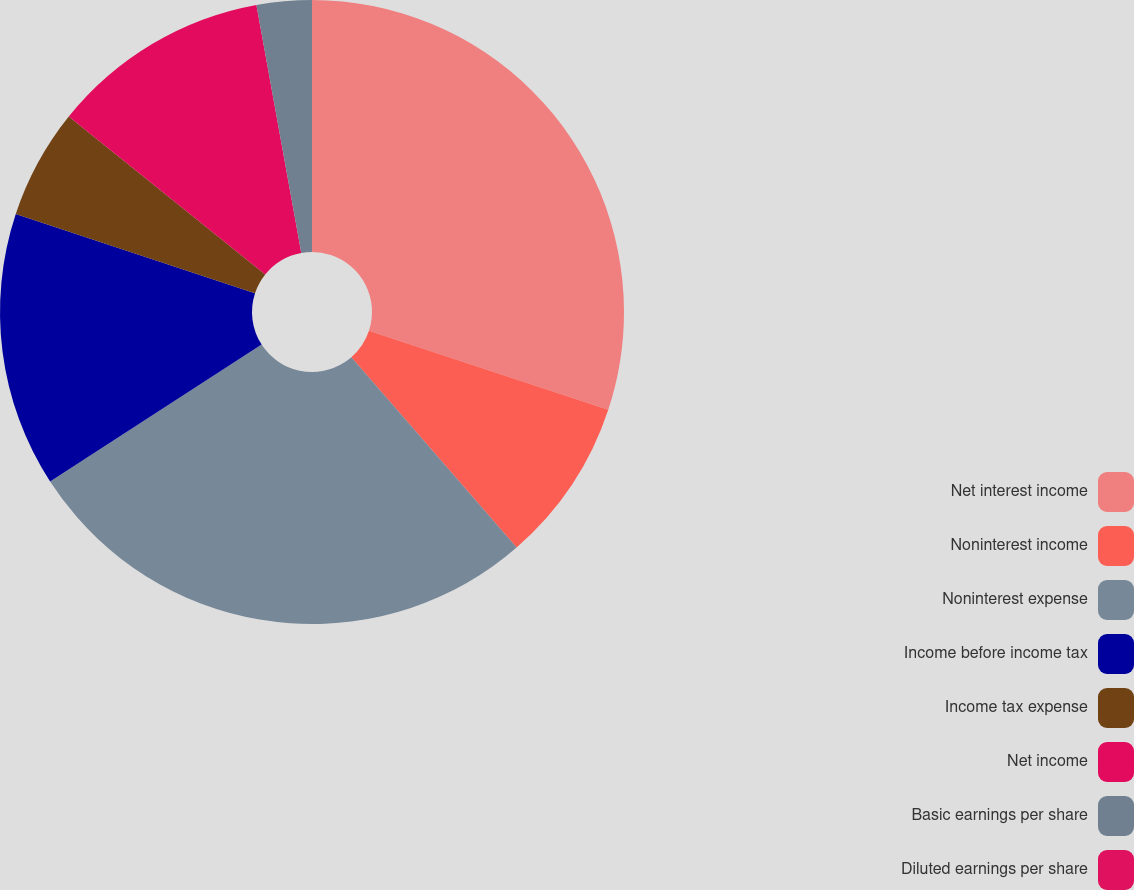Convert chart. <chart><loc_0><loc_0><loc_500><loc_500><pie_chart><fcel>Net interest income<fcel>Noninterest income<fcel>Noninterest expense<fcel>Income before income tax<fcel>Income tax expense<fcel>Net income<fcel>Basic earnings per share<fcel>Diluted earnings per share<nl><fcel>30.08%<fcel>8.54%<fcel>27.24%<fcel>14.23%<fcel>5.69%<fcel>11.38%<fcel>2.85%<fcel>0.0%<nl></chart> 